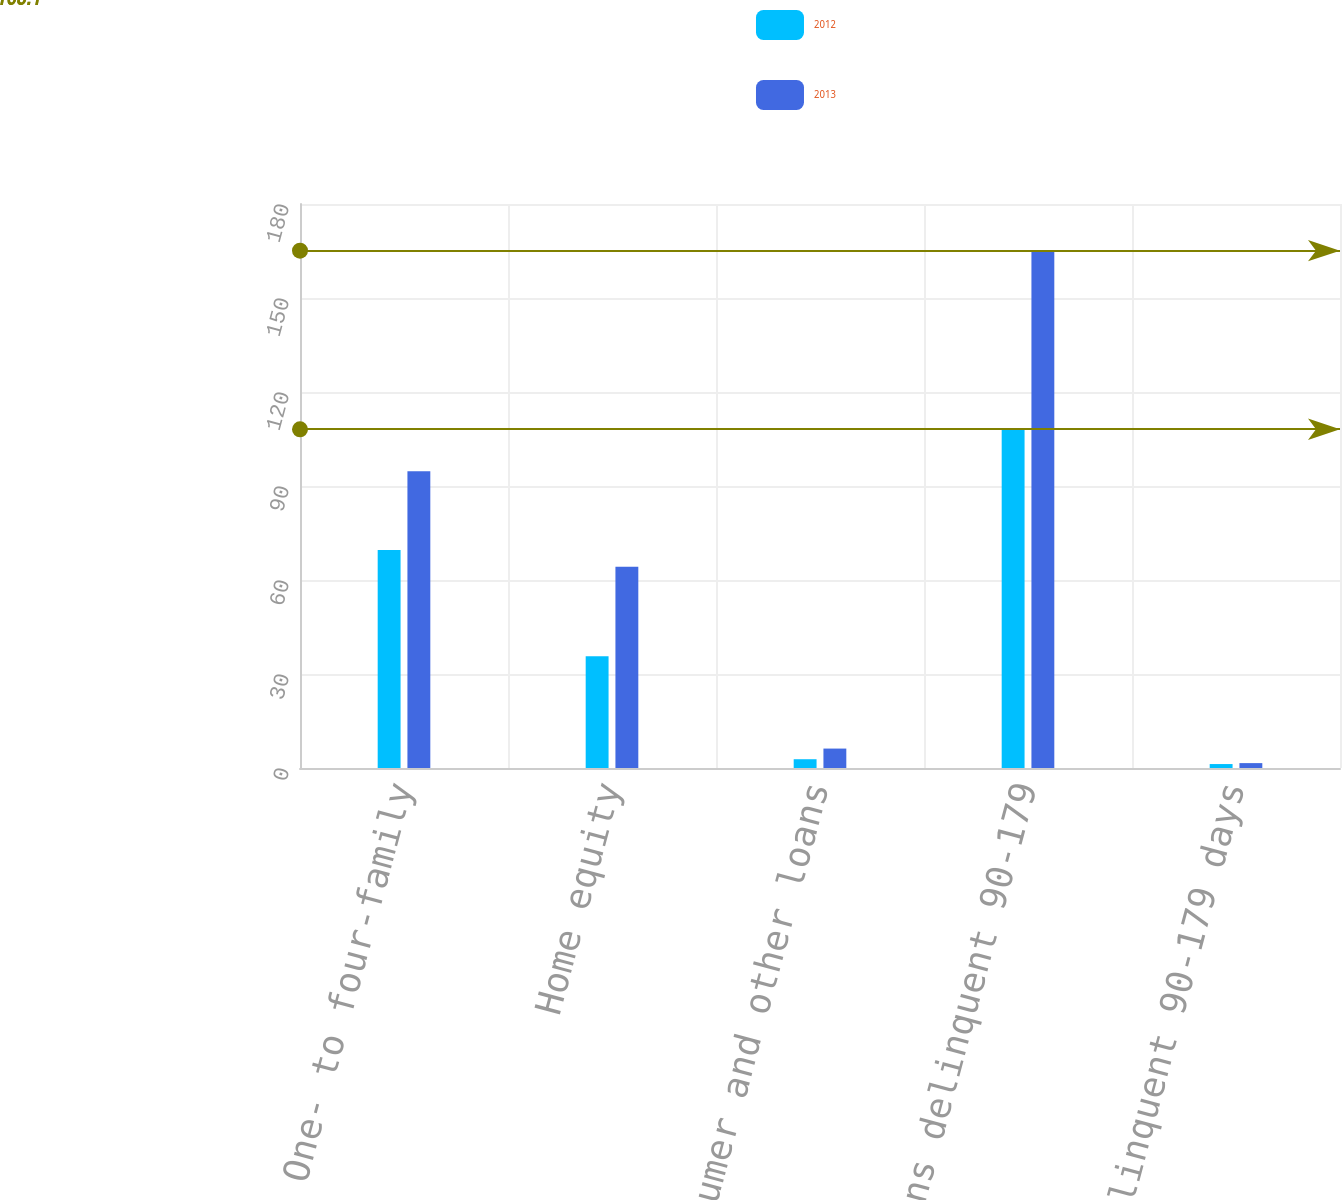Convert chart. <chart><loc_0><loc_0><loc_500><loc_500><stacked_bar_chart><ecel><fcel>One- to four-family<fcel>Home equity<fcel>Consumer and other loans<fcel>Total loans delinquent 90-179<fcel>Loans delinquent 90-179 days<nl><fcel>2012<fcel>69.6<fcel>35.7<fcel>2.8<fcel>108.1<fcel>1.26<nl><fcel>2013<fcel>94.7<fcel>64.2<fcel>6.2<fcel>165.1<fcel>1.56<nl></chart> 